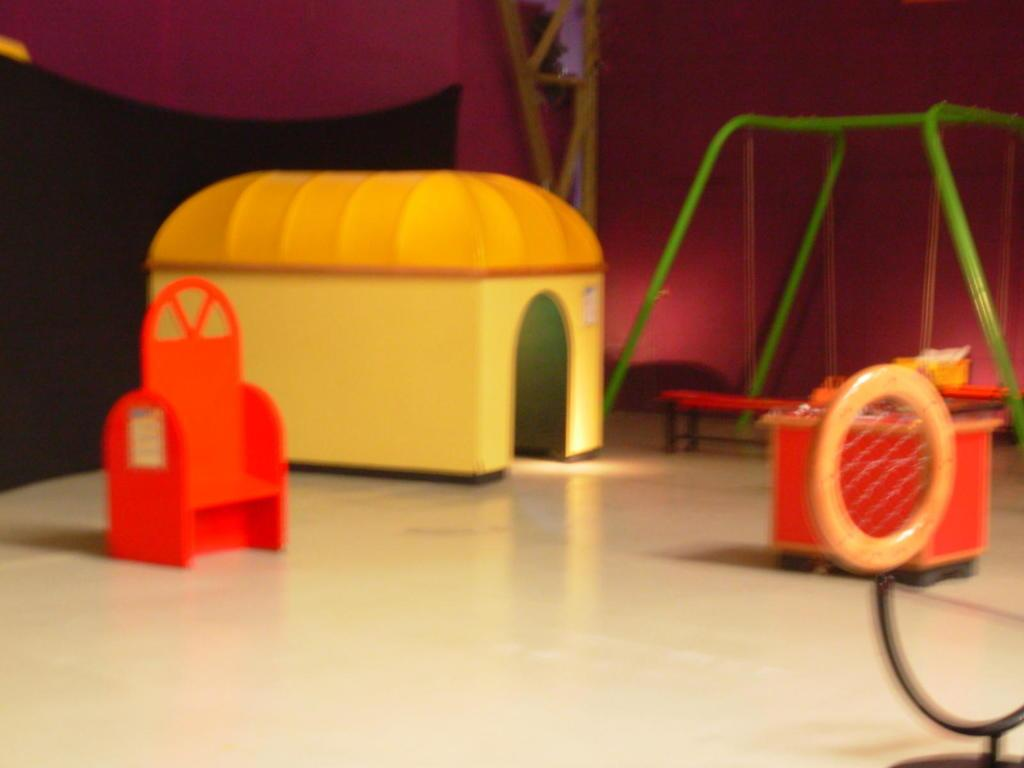What objects are on the table in the image? There are toys on a table in the image. Can you describe the background of the image? There is a person, a stand, and a wall in the background of the image. How many giraffes can be seen in the image? There are no giraffes present in the image. Is there a baby playing with the toys in the image? The provided facts do not mention a baby or any indication of a baby playing with the toys in the image. 